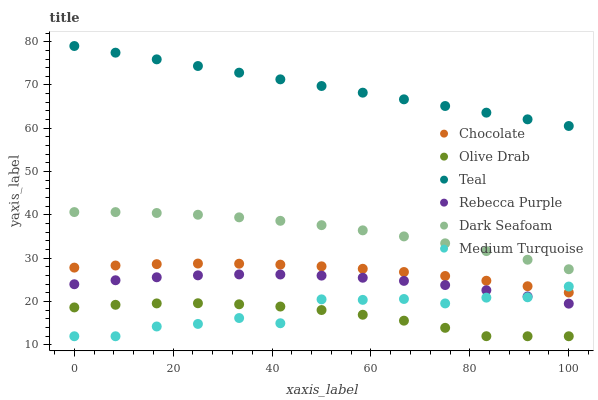Does Olive Drab have the minimum area under the curve?
Answer yes or no. Yes. Does Teal have the maximum area under the curve?
Answer yes or no. Yes. Does Chocolate have the minimum area under the curve?
Answer yes or no. No. Does Chocolate have the maximum area under the curve?
Answer yes or no. No. Is Teal the smoothest?
Answer yes or no. Yes. Is Medium Turquoise the roughest?
Answer yes or no. Yes. Is Chocolate the smoothest?
Answer yes or no. No. Is Chocolate the roughest?
Answer yes or no. No. Does Medium Turquoise have the lowest value?
Answer yes or no. Yes. Does Chocolate have the lowest value?
Answer yes or no. No. Does Teal have the highest value?
Answer yes or no. Yes. Does Chocolate have the highest value?
Answer yes or no. No. Is Dark Seafoam less than Teal?
Answer yes or no. Yes. Is Dark Seafoam greater than Olive Drab?
Answer yes or no. Yes. Does Chocolate intersect Medium Turquoise?
Answer yes or no. Yes. Is Chocolate less than Medium Turquoise?
Answer yes or no. No. Is Chocolate greater than Medium Turquoise?
Answer yes or no. No. Does Dark Seafoam intersect Teal?
Answer yes or no. No. 